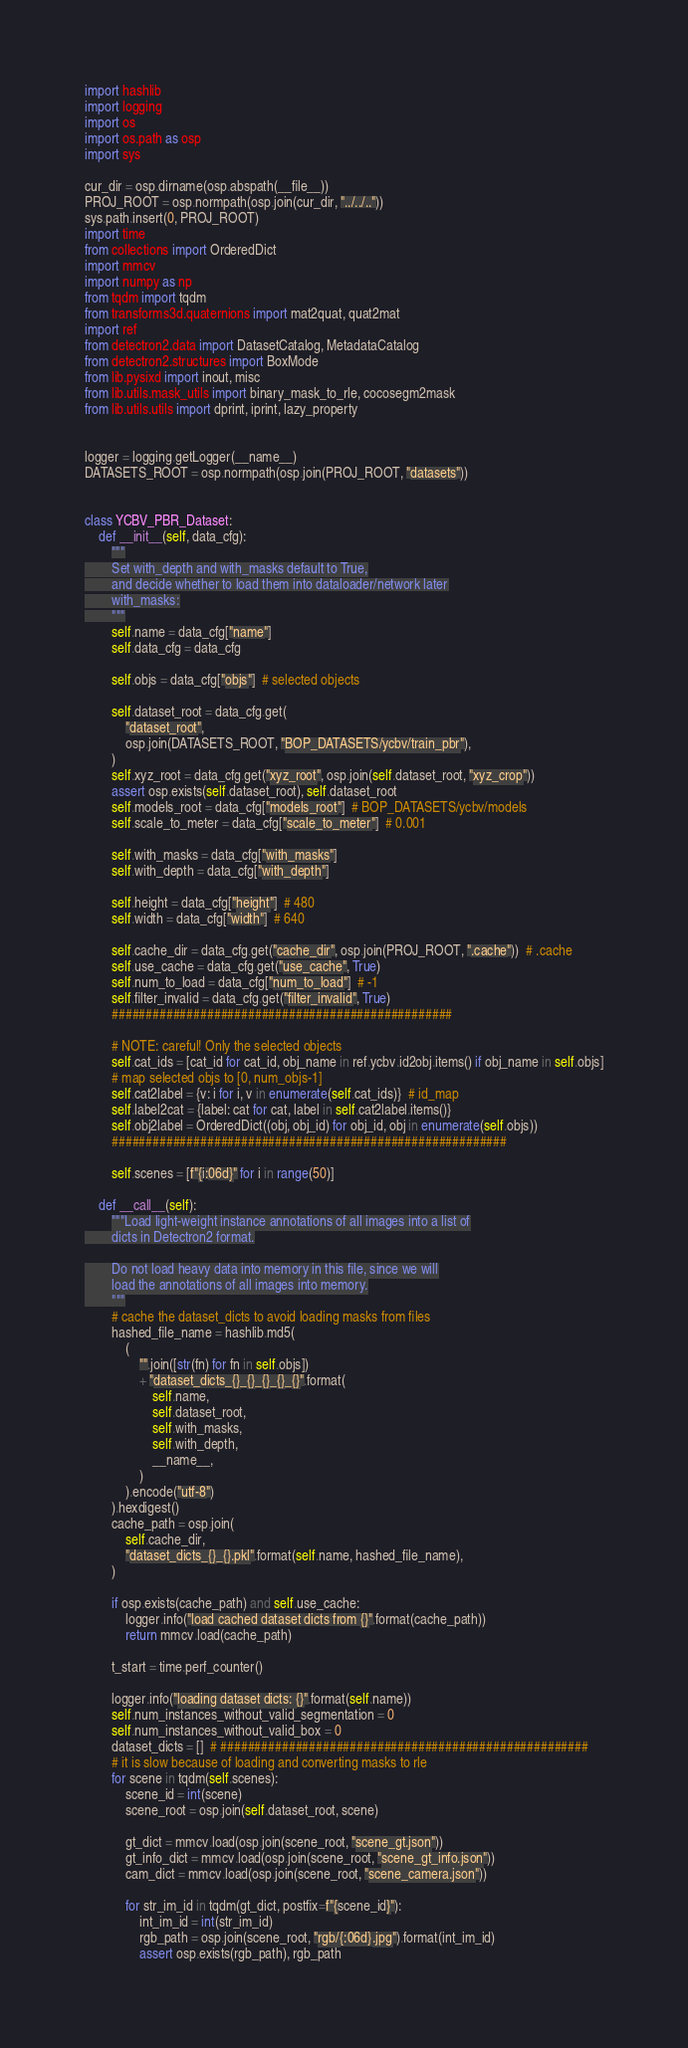Convert code to text. <code><loc_0><loc_0><loc_500><loc_500><_Python_>import hashlib
import logging
import os
import os.path as osp
import sys

cur_dir = osp.dirname(osp.abspath(__file__))
PROJ_ROOT = osp.normpath(osp.join(cur_dir, "../../.."))
sys.path.insert(0, PROJ_ROOT)
import time
from collections import OrderedDict
import mmcv
import numpy as np
from tqdm import tqdm
from transforms3d.quaternions import mat2quat, quat2mat
import ref
from detectron2.data import DatasetCatalog, MetadataCatalog
from detectron2.structures import BoxMode
from lib.pysixd import inout, misc
from lib.utils.mask_utils import binary_mask_to_rle, cocosegm2mask
from lib.utils.utils import dprint, iprint, lazy_property


logger = logging.getLogger(__name__)
DATASETS_ROOT = osp.normpath(osp.join(PROJ_ROOT, "datasets"))


class YCBV_PBR_Dataset:
    def __init__(self, data_cfg):
        """
        Set with_depth and with_masks default to True,
        and decide whether to load them into dataloader/network later
        with_masks:
        """
        self.name = data_cfg["name"]
        self.data_cfg = data_cfg

        self.objs = data_cfg["objs"]  # selected objects

        self.dataset_root = data_cfg.get(
            "dataset_root",
            osp.join(DATASETS_ROOT, "BOP_DATASETS/ycbv/train_pbr"),
        )
        self.xyz_root = data_cfg.get("xyz_root", osp.join(self.dataset_root, "xyz_crop"))
        assert osp.exists(self.dataset_root), self.dataset_root
        self.models_root = data_cfg["models_root"]  # BOP_DATASETS/ycbv/models
        self.scale_to_meter = data_cfg["scale_to_meter"]  # 0.001

        self.with_masks = data_cfg["with_masks"]
        self.with_depth = data_cfg["with_depth"]

        self.height = data_cfg["height"]  # 480
        self.width = data_cfg["width"]  # 640

        self.cache_dir = data_cfg.get("cache_dir", osp.join(PROJ_ROOT, ".cache"))  # .cache
        self.use_cache = data_cfg.get("use_cache", True)
        self.num_to_load = data_cfg["num_to_load"]  # -1
        self.filter_invalid = data_cfg.get("filter_invalid", True)
        ##################################################

        # NOTE: careful! Only the selected objects
        self.cat_ids = [cat_id for cat_id, obj_name in ref.ycbv.id2obj.items() if obj_name in self.objs]
        # map selected objs to [0, num_objs-1]
        self.cat2label = {v: i for i, v in enumerate(self.cat_ids)}  # id_map
        self.label2cat = {label: cat for cat, label in self.cat2label.items()}
        self.obj2label = OrderedDict((obj, obj_id) for obj_id, obj in enumerate(self.objs))
        ##########################################################

        self.scenes = [f"{i:06d}" for i in range(50)]

    def __call__(self):
        """Load light-weight instance annotations of all images into a list of
        dicts in Detectron2 format.

        Do not load heavy data into memory in this file, since we will
        load the annotations of all images into memory.
        """
        # cache the dataset_dicts to avoid loading masks from files
        hashed_file_name = hashlib.md5(
            (
                "".join([str(fn) for fn in self.objs])
                + "dataset_dicts_{}_{}_{}_{}_{}".format(
                    self.name,
                    self.dataset_root,
                    self.with_masks,
                    self.with_depth,
                    __name__,
                )
            ).encode("utf-8")
        ).hexdigest()
        cache_path = osp.join(
            self.cache_dir,
            "dataset_dicts_{}_{}.pkl".format(self.name, hashed_file_name),
        )

        if osp.exists(cache_path) and self.use_cache:
            logger.info("load cached dataset dicts from {}".format(cache_path))
            return mmcv.load(cache_path)

        t_start = time.perf_counter()

        logger.info("loading dataset dicts: {}".format(self.name))
        self.num_instances_without_valid_segmentation = 0
        self.num_instances_without_valid_box = 0
        dataset_dicts = []  # ######################################################
        # it is slow because of loading and converting masks to rle
        for scene in tqdm(self.scenes):
            scene_id = int(scene)
            scene_root = osp.join(self.dataset_root, scene)

            gt_dict = mmcv.load(osp.join(scene_root, "scene_gt.json"))
            gt_info_dict = mmcv.load(osp.join(scene_root, "scene_gt_info.json"))
            cam_dict = mmcv.load(osp.join(scene_root, "scene_camera.json"))

            for str_im_id in tqdm(gt_dict, postfix=f"{scene_id}"):
                int_im_id = int(str_im_id)
                rgb_path = osp.join(scene_root, "rgb/{:06d}.jpg").format(int_im_id)
                assert osp.exists(rgb_path), rgb_path
</code> 